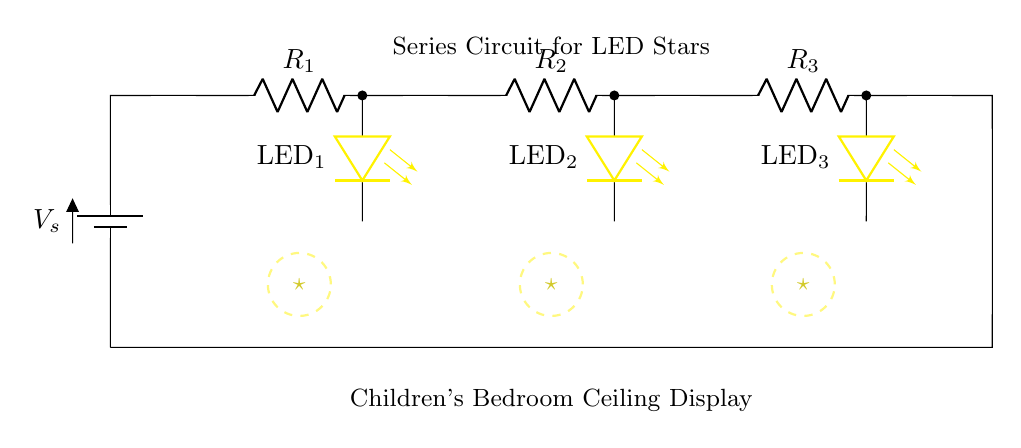What is the voltage source in this circuit? The voltage source is denoted as Vs, which is located at the top left of the circuit diagram.
Answer: Vs How many resistors are present in the circuit? There are three resistors, R1, R2, and R3, shown in series with the LED lights.
Answer: 3 What color are the LED stars in this circuit? The LED stars are colored yellow, as indicated by the color label next to the LED symbols.
Answer: Yellow Which components are connected in series in this circuit? All components including the battery, resistors, and LEDs are connected in series, meaning the current through each component is the same.
Answer: Battery, R1, R2, R3, LED1, LED2, LED3 If one LED fails, what happens to the rest of the circuit? If one LED fails, the circuit will be broken (open circuit), and all LEDs will go out because current cannot flow past the failed LED.
Answer: All go out What is the purpose of the resistors in this circuit? The resistors limit the current flowing through the LEDs to prevent them from burning out due to excessive current.
Answer: Limit current 